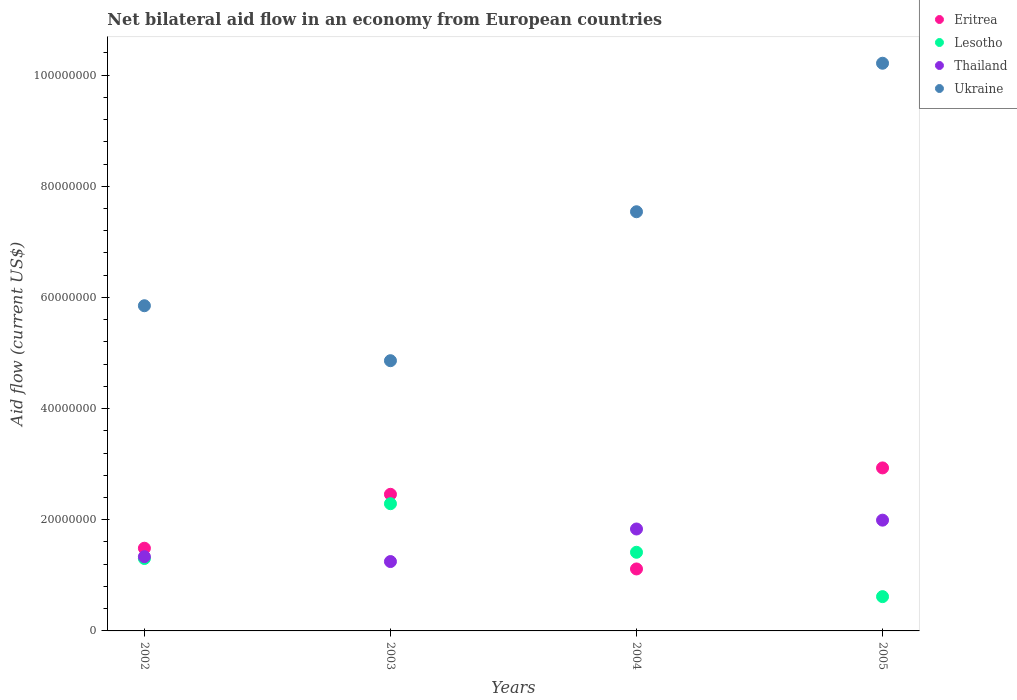What is the net bilateral aid flow in Lesotho in 2003?
Provide a short and direct response. 2.29e+07. Across all years, what is the maximum net bilateral aid flow in Thailand?
Keep it short and to the point. 1.99e+07. Across all years, what is the minimum net bilateral aid flow in Ukraine?
Provide a succinct answer. 4.86e+07. In which year was the net bilateral aid flow in Thailand maximum?
Keep it short and to the point. 2005. What is the total net bilateral aid flow in Lesotho in the graph?
Offer a terse response. 5.62e+07. What is the difference between the net bilateral aid flow in Thailand in 2003 and that in 2004?
Offer a terse response. -5.86e+06. What is the difference between the net bilateral aid flow in Eritrea in 2003 and the net bilateral aid flow in Ukraine in 2005?
Make the answer very short. -7.76e+07. What is the average net bilateral aid flow in Ukraine per year?
Provide a short and direct response. 7.12e+07. In the year 2002, what is the difference between the net bilateral aid flow in Ukraine and net bilateral aid flow in Eritrea?
Give a very brief answer. 4.36e+07. What is the ratio of the net bilateral aid flow in Thailand in 2002 to that in 2003?
Give a very brief answer. 1.07. Is the difference between the net bilateral aid flow in Ukraine in 2003 and 2005 greater than the difference between the net bilateral aid flow in Eritrea in 2003 and 2005?
Offer a very short reply. No. What is the difference between the highest and the second highest net bilateral aid flow in Lesotho?
Give a very brief answer. 8.74e+06. What is the difference between the highest and the lowest net bilateral aid flow in Thailand?
Offer a very short reply. 7.45e+06. In how many years, is the net bilateral aid flow in Lesotho greater than the average net bilateral aid flow in Lesotho taken over all years?
Your answer should be compact. 2. Is the net bilateral aid flow in Thailand strictly less than the net bilateral aid flow in Eritrea over the years?
Keep it short and to the point. No. How many years are there in the graph?
Provide a succinct answer. 4. Are the values on the major ticks of Y-axis written in scientific E-notation?
Provide a succinct answer. No. Does the graph contain any zero values?
Make the answer very short. No. Where does the legend appear in the graph?
Offer a very short reply. Top right. How are the legend labels stacked?
Your answer should be compact. Vertical. What is the title of the graph?
Provide a short and direct response. Net bilateral aid flow in an economy from European countries. Does "Euro area" appear as one of the legend labels in the graph?
Your response must be concise. No. What is the label or title of the X-axis?
Your answer should be very brief. Years. What is the Aid flow (current US$) in Eritrea in 2002?
Offer a very short reply. 1.49e+07. What is the Aid flow (current US$) in Lesotho in 2002?
Ensure brevity in your answer.  1.30e+07. What is the Aid flow (current US$) of Thailand in 2002?
Your response must be concise. 1.34e+07. What is the Aid flow (current US$) of Ukraine in 2002?
Ensure brevity in your answer.  5.85e+07. What is the Aid flow (current US$) in Eritrea in 2003?
Provide a succinct answer. 2.46e+07. What is the Aid flow (current US$) of Lesotho in 2003?
Make the answer very short. 2.29e+07. What is the Aid flow (current US$) of Thailand in 2003?
Your answer should be compact. 1.25e+07. What is the Aid flow (current US$) of Ukraine in 2003?
Provide a succinct answer. 4.86e+07. What is the Aid flow (current US$) in Eritrea in 2004?
Offer a very short reply. 1.12e+07. What is the Aid flow (current US$) of Lesotho in 2004?
Ensure brevity in your answer.  1.42e+07. What is the Aid flow (current US$) in Thailand in 2004?
Your answer should be compact. 1.83e+07. What is the Aid flow (current US$) in Ukraine in 2004?
Your response must be concise. 7.54e+07. What is the Aid flow (current US$) in Eritrea in 2005?
Ensure brevity in your answer.  2.93e+07. What is the Aid flow (current US$) in Lesotho in 2005?
Keep it short and to the point. 6.17e+06. What is the Aid flow (current US$) of Thailand in 2005?
Provide a short and direct response. 1.99e+07. What is the Aid flow (current US$) of Ukraine in 2005?
Offer a terse response. 1.02e+08. Across all years, what is the maximum Aid flow (current US$) in Eritrea?
Provide a succinct answer. 2.93e+07. Across all years, what is the maximum Aid flow (current US$) of Lesotho?
Make the answer very short. 2.29e+07. Across all years, what is the maximum Aid flow (current US$) of Thailand?
Provide a succinct answer. 1.99e+07. Across all years, what is the maximum Aid flow (current US$) in Ukraine?
Your response must be concise. 1.02e+08. Across all years, what is the minimum Aid flow (current US$) of Eritrea?
Your answer should be compact. 1.12e+07. Across all years, what is the minimum Aid flow (current US$) in Lesotho?
Give a very brief answer. 6.17e+06. Across all years, what is the minimum Aid flow (current US$) of Thailand?
Ensure brevity in your answer.  1.25e+07. Across all years, what is the minimum Aid flow (current US$) of Ukraine?
Offer a very short reply. 4.86e+07. What is the total Aid flow (current US$) in Eritrea in the graph?
Give a very brief answer. 7.99e+07. What is the total Aid flow (current US$) of Lesotho in the graph?
Your response must be concise. 5.62e+07. What is the total Aid flow (current US$) in Thailand in the graph?
Keep it short and to the point. 6.41e+07. What is the total Aid flow (current US$) of Ukraine in the graph?
Make the answer very short. 2.85e+08. What is the difference between the Aid flow (current US$) in Eritrea in 2002 and that in 2003?
Keep it short and to the point. -9.70e+06. What is the difference between the Aid flow (current US$) of Lesotho in 2002 and that in 2003?
Keep it short and to the point. -9.86e+06. What is the difference between the Aid flow (current US$) of Thailand in 2002 and that in 2003?
Your answer should be very brief. 8.80e+05. What is the difference between the Aid flow (current US$) in Ukraine in 2002 and that in 2003?
Make the answer very short. 9.89e+06. What is the difference between the Aid flow (current US$) in Eritrea in 2002 and that in 2004?
Provide a short and direct response. 3.73e+06. What is the difference between the Aid flow (current US$) of Lesotho in 2002 and that in 2004?
Ensure brevity in your answer.  -1.12e+06. What is the difference between the Aid flow (current US$) of Thailand in 2002 and that in 2004?
Your answer should be compact. -4.98e+06. What is the difference between the Aid flow (current US$) in Ukraine in 2002 and that in 2004?
Ensure brevity in your answer.  -1.69e+07. What is the difference between the Aid flow (current US$) of Eritrea in 2002 and that in 2005?
Offer a very short reply. -1.44e+07. What is the difference between the Aid flow (current US$) of Lesotho in 2002 and that in 2005?
Your answer should be compact. 6.86e+06. What is the difference between the Aid flow (current US$) of Thailand in 2002 and that in 2005?
Your answer should be very brief. -6.57e+06. What is the difference between the Aid flow (current US$) in Ukraine in 2002 and that in 2005?
Your answer should be compact. -4.36e+07. What is the difference between the Aid flow (current US$) of Eritrea in 2003 and that in 2004?
Provide a short and direct response. 1.34e+07. What is the difference between the Aid flow (current US$) of Lesotho in 2003 and that in 2004?
Keep it short and to the point. 8.74e+06. What is the difference between the Aid flow (current US$) in Thailand in 2003 and that in 2004?
Keep it short and to the point. -5.86e+06. What is the difference between the Aid flow (current US$) of Ukraine in 2003 and that in 2004?
Offer a very short reply. -2.68e+07. What is the difference between the Aid flow (current US$) in Eritrea in 2003 and that in 2005?
Ensure brevity in your answer.  -4.75e+06. What is the difference between the Aid flow (current US$) of Lesotho in 2003 and that in 2005?
Your answer should be very brief. 1.67e+07. What is the difference between the Aid flow (current US$) in Thailand in 2003 and that in 2005?
Keep it short and to the point. -7.45e+06. What is the difference between the Aid flow (current US$) in Ukraine in 2003 and that in 2005?
Give a very brief answer. -5.35e+07. What is the difference between the Aid flow (current US$) in Eritrea in 2004 and that in 2005?
Ensure brevity in your answer.  -1.82e+07. What is the difference between the Aid flow (current US$) in Lesotho in 2004 and that in 2005?
Offer a very short reply. 7.98e+06. What is the difference between the Aid flow (current US$) in Thailand in 2004 and that in 2005?
Offer a very short reply. -1.59e+06. What is the difference between the Aid flow (current US$) in Ukraine in 2004 and that in 2005?
Give a very brief answer. -2.67e+07. What is the difference between the Aid flow (current US$) of Eritrea in 2002 and the Aid flow (current US$) of Lesotho in 2003?
Give a very brief answer. -8.01e+06. What is the difference between the Aid flow (current US$) of Eritrea in 2002 and the Aid flow (current US$) of Thailand in 2003?
Make the answer very short. 2.40e+06. What is the difference between the Aid flow (current US$) of Eritrea in 2002 and the Aid flow (current US$) of Ukraine in 2003?
Provide a succinct answer. -3.37e+07. What is the difference between the Aid flow (current US$) in Lesotho in 2002 and the Aid flow (current US$) in Ukraine in 2003?
Provide a short and direct response. -3.56e+07. What is the difference between the Aid flow (current US$) of Thailand in 2002 and the Aid flow (current US$) of Ukraine in 2003?
Offer a terse response. -3.53e+07. What is the difference between the Aid flow (current US$) of Eritrea in 2002 and the Aid flow (current US$) of Lesotho in 2004?
Offer a very short reply. 7.30e+05. What is the difference between the Aid flow (current US$) of Eritrea in 2002 and the Aid flow (current US$) of Thailand in 2004?
Make the answer very short. -3.46e+06. What is the difference between the Aid flow (current US$) of Eritrea in 2002 and the Aid flow (current US$) of Ukraine in 2004?
Your response must be concise. -6.05e+07. What is the difference between the Aid flow (current US$) in Lesotho in 2002 and the Aid flow (current US$) in Thailand in 2004?
Your answer should be very brief. -5.31e+06. What is the difference between the Aid flow (current US$) of Lesotho in 2002 and the Aid flow (current US$) of Ukraine in 2004?
Keep it short and to the point. -6.24e+07. What is the difference between the Aid flow (current US$) in Thailand in 2002 and the Aid flow (current US$) in Ukraine in 2004?
Keep it short and to the point. -6.21e+07. What is the difference between the Aid flow (current US$) of Eritrea in 2002 and the Aid flow (current US$) of Lesotho in 2005?
Your answer should be compact. 8.71e+06. What is the difference between the Aid flow (current US$) of Eritrea in 2002 and the Aid flow (current US$) of Thailand in 2005?
Your response must be concise. -5.05e+06. What is the difference between the Aid flow (current US$) in Eritrea in 2002 and the Aid flow (current US$) in Ukraine in 2005?
Make the answer very short. -8.73e+07. What is the difference between the Aid flow (current US$) in Lesotho in 2002 and the Aid flow (current US$) in Thailand in 2005?
Make the answer very short. -6.90e+06. What is the difference between the Aid flow (current US$) of Lesotho in 2002 and the Aid flow (current US$) of Ukraine in 2005?
Give a very brief answer. -8.91e+07. What is the difference between the Aid flow (current US$) of Thailand in 2002 and the Aid flow (current US$) of Ukraine in 2005?
Provide a short and direct response. -8.88e+07. What is the difference between the Aid flow (current US$) in Eritrea in 2003 and the Aid flow (current US$) in Lesotho in 2004?
Your answer should be very brief. 1.04e+07. What is the difference between the Aid flow (current US$) in Eritrea in 2003 and the Aid flow (current US$) in Thailand in 2004?
Offer a terse response. 6.24e+06. What is the difference between the Aid flow (current US$) of Eritrea in 2003 and the Aid flow (current US$) of Ukraine in 2004?
Offer a terse response. -5.08e+07. What is the difference between the Aid flow (current US$) in Lesotho in 2003 and the Aid flow (current US$) in Thailand in 2004?
Provide a succinct answer. 4.55e+06. What is the difference between the Aid flow (current US$) in Lesotho in 2003 and the Aid flow (current US$) in Ukraine in 2004?
Provide a succinct answer. -5.25e+07. What is the difference between the Aid flow (current US$) in Thailand in 2003 and the Aid flow (current US$) in Ukraine in 2004?
Offer a terse response. -6.29e+07. What is the difference between the Aid flow (current US$) of Eritrea in 2003 and the Aid flow (current US$) of Lesotho in 2005?
Provide a short and direct response. 1.84e+07. What is the difference between the Aid flow (current US$) of Eritrea in 2003 and the Aid flow (current US$) of Thailand in 2005?
Your answer should be compact. 4.65e+06. What is the difference between the Aid flow (current US$) of Eritrea in 2003 and the Aid flow (current US$) of Ukraine in 2005?
Your answer should be compact. -7.76e+07. What is the difference between the Aid flow (current US$) of Lesotho in 2003 and the Aid flow (current US$) of Thailand in 2005?
Make the answer very short. 2.96e+06. What is the difference between the Aid flow (current US$) in Lesotho in 2003 and the Aid flow (current US$) in Ukraine in 2005?
Keep it short and to the point. -7.92e+07. What is the difference between the Aid flow (current US$) of Thailand in 2003 and the Aid flow (current US$) of Ukraine in 2005?
Give a very brief answer. -8.97e+07. What is the difference between the Aid flow (current US$) of Eritrea in 2004 and the Aid flow (current US$) of Lesotho in 2005?
Your answer should be compact. 4.98e+06. What is the difference between the Aid flow (current US$) in Eritrea in 2004 and the Aid flow (current US$) in Thailand in 2005?
Your answer should be compact. -8.78e+06. What is the difference between the Aid flow (current US$) in Eritrea in 2004 and the Aid flow (current US$) in Ukraine in 2005?
Offer a terse response. -9.10e+07. What is the difference between the Aid flow (current US$) of Lesotho in 2004 and the Aid flow (current US$) of Thailand in 2005?
Keep it short and to the point. -5.78e+06. What is the difference between the Aid flow (current US$) of Lesotho in 2004 and the Aid flow (current US$) of Ukraine in 2005?
Provide a short and direct response. -8.80e+07. What is the difference between the Aid flow (current US$) in Thailand in 2004 and the Aid flow (current US$) in Ukraine in 2005?
Keep it short and to the point. -8.38e+07. What is the average Aid flow (current US$) in Eritrea per year?
Provide a short and direct response. 2.00e+07. What is the average Aid flow (current US$) of Lesotho per year?
Make the answer very short. 1.41e+07. What is the average Aid flow (current US$) of Thailand per year?
Provide a short and direct response. 1.60e+07. What is the average Aid flow (current US$) of Ukraine per year?
Ensure brevity in your answer.  7.12e+07. In the year 2002, what is the difference between the Aid flow (current US$) of Eritrea and Aid flow (current US$) of Lesotho?
Your answer should be very brief. 1.85e+06. In the year 2002, what is the difference between the Aid flow (current US$) of Eritrea and Aid flow (current US$) of Thailand?
Provide a succinct answer. 1.52e+06. In the year 2002, what is the difference between the Aid flow (current US$) of Eritrea and Aid flow (current US$) of Ukraine?
Make the answer very short. -4.36e+07. In the year 2002, what is the difference between the Aid flow (current US$) of Lesotho and Aid flow (current US$) of Thailand?
Offer a terse response. -3.30e+05. In the year 2002, what is the difference between the Aid flow (current US$) in Lesotho and Aid flow (current US$) in Ukraine?
Offer a terse response. -4.55e+07. In the year 2002, what is the difference between the Aid flow (current US$) in Thailand and Aid flow (current US$) in Ukraine?
Ensure brevity in your answer.  -4.52e+07. In the year 2003, what is the difference between the Aid flow (current US$) in Eritrea and Aid flow (current US$) in Lesotho?
Your answer should be compact. 1.69e+06. In the year 2003, what is the difference between the Aid flow (current US$) in Eritrea and Aid flow (current US$) in Thailand?
Keep it short and to the point. 1.21e+07. In the year 2003, what is the difference between the Aid flow (current US$) of Eritrea and Aid flow (current US$) of Ukraine?
Offer a terse response. -2.40e+07. In the year 2003, what is the difference between the Aid flow (current US$) of Lesotho and Aid flow (current US$) of Thailand?
Keep it short and to the point. 1.04e+07. In the year 2003, what is the difference between the Aid flow (current US$) of Lesotho and Aid flow (current US$) of Ukraine?
Offer a terse response. -2.57e+07. In the year 2003, what is the difference between the Aid flow (current US$) of Thailand and Aid flow (current US$) of Ukraine?
Give a very brief answer. -3.61e+07. In the year 2004, what is the difference between the Aid flow (current US$) of Eritrea and Aid flow (current US$) of Lesotho?
Offer a very short reply. -3.00e+06. In the year 2004, what is the difference between the Aid flow (current US$) of Eritrea and Aid flow (current US$) of Thailand?
Your answer should be very brief. -7.19e+06. In the year 2004, what is the difference between the Aid flow (current US$) of Eritrea and Aid flow (current US$) of Ukraine?
Give a very brief answer. -6.43e+07. In the year 2004, what is the difference between the Aid flow (current US$) of Lesotho and Aid flow (current US$) of Thailand?
Provide a short and direct response. -4.19e+06. In the year 2004, what is the difference between the Aid flow (current US$) of Lesotho and Aid flow (current US$) of Ukraine?
Keep it short and to the point. -6.13e+07. In the year 2004, what is the difference between the Aid flow (current US$) of Thailand and Aid flow (current US$) of Ukraine?
Your answer should be compact. -5.71e+07. In the year 2005, what is the difference between the Aid flow (current US$) in Eritrea and Aid flow (current US$) in Lesotho?
Your answer should be compact. 2.32e+07. In the year 2005, what is the difference between the Aid flow (current US$) in Eritrea and Aid flow (current US$) in Thailand?
Provide a short and direct response. 9.40e+06. In the year 2005, what is the difference between the Aid flow (current US$) of Eritrea and Aid flow (current US$) of Ukraine?
Your response must be concise. -7.28e+07. In the year 2005, what is the difference between the Aid flow (current US$) in Lesotho and Aid flow (current US$) in Thailand?
Provide a succinct answer. -1.38e+07. In the year 2005, what is the difference between the Aid flow (current US$) in Lesotho and Aid flow (current US$) in Ukraine?
Offer a very short reply. -9.60e+07. In the year 2005, what is the difference between the Aid flow (current US$) in Thailand and Aid flow (current US$) in Ukraine?
Offer a very short reply. -8.22e+07. What is the ratio of the Aid flow (current US$) in Eritrea in 2002 to that in 2003?
Keep it short and to the point. 0.61. What is the ratio of the Aid flow (current US$) in Lesotho in 2002 to that in 2003?
Make the answer very short. 0.57. What is the ratio of the Aid flow (current US$) in Thailand in 2002 to that in 2003?
Provide a short and direct response. 1.07. What is the ratio of the Aid flow (current US$) of Ukraine in 2002 to that in 2003?
Offer a very short reply. 1.2. What is the ratio of the Aid flow (current US$) of Eritrea in 2002 to that in 2004?
Offer a very short reply. 1.33. What is the ratio of the Aid flow (current US$) of Lesotho in 2002 to that in 2004?
Your answer should be very brief. 0.92. What is the ratio of the Aid flow (current US$) in Thailand in 2002 to that in 2004?
Offer a terse response. 0.73. What is the ratio of the Aid flow (current US$) of Ukraine in 2002 to that in 2004?
Your answer should be very brief. 0.78. What is the ratio of the Aid flow (current US$) of Eritrea in 2002 to that in 2005?
Offer a very short reply. 0.51. What is the ratio of the Aid flow (current US$) in Lesotho in 2002 to that in 2005?
Provide a succinct answer. 2.11. What is the ratio of the Aid flow (current US$) of Thailand in 2002 to that in 2005?
Make the answer very short. 0.67. What is the ratio of the Aid flow (current US$) in Ukraine in 2002 to that in 2005?
Offer a very short reply. 0.57. What is the ratio of the Aid flow (current US$) in Eritrea in 2003 to that in 2004?
Make the answer very short. 2.2. What is the ratio of the Aid flow (current US$) in Lesotho in 2003 to that in 2004?
Ensure brevity in your answer.  1.62. What is the ratio of the Aid flow (current US$) in Thailand in 2003 to that in 2004?
Your answer should be very brief. 0.68. What is the ratio of the Aid flow (current US$) of Ukraine in 2003 to that in 2004?
Ensure brevity in your answer.  0.64. What is the ratio of the Aid flow (current US$) in Eritrea in 2003 to that in 2005?
Keep it short and to the point. 0.84. What is the ratio of the Aid flow (current US$) of Lesotho in 2003 to that in 2005?
Keep it short and to the point. 3.71. What is the ratio of the Aid flow (current US$) in Thailand in 2003 to that in 2005?
Provide a short and direct response. 0.63. What is the ratio of the Aid flow (current US$) of Ukraine in 2003 to that in 2005?
Provide a short and direct response. 0.48. What is the ratio of the Aid flow (current US$) of Eritrea in 2004 to that in 2005?
Your response must be concise. 0.38. What is the ratio of the Aid flow (current US$) in Lesotho in 2004 to that in 2005?
Your answer should be very brief. 2.29. What is the ratio of the Aid flow (current US$) in Thailand in 2004 to that in 2005?
Provide a short and direct response. 0.92. What is the ratio of the Aid flow (current US$) of Ukraine in 2004 to that in 2005?
Your answer should be very brief. 0.74. What is the difference between the highest and the second highest Aid flow (current US$) of Eritrea?
Your response must be concise. 4.75e+06. What is the difference between the highest and the second highest Aid flow (current US$) of Lesotho?
Offer a very short reply. 8.74e+06. What is the difference between the highest and the second highest Aid flow (current US$) in Thailand?
Make the answer very short. 1.59e+06. What is the difference between the highest and the second highest Aid flow (current US$) in Ukraine?
Provide a succinct answer. 2.67e+07. What is the difference between the highest and the lowest Aid flow (current US$) in Eritrea?
Your response must be concise. 1.82e+07. What is the difference between the highest and the lowest Aid flow (current US$) in Lesotho?
Ensure brevity in your answer.  1.67e+07. What is the difference between the highest and the lowest Aid flow (current US$) in Thailand?
Give a very brief answer. 7.45e+06. What is the difference between the highest and the lowest Aid flow (current US$) in Ukraine?
Ensure brevity in your answer.  5.35e+07. 